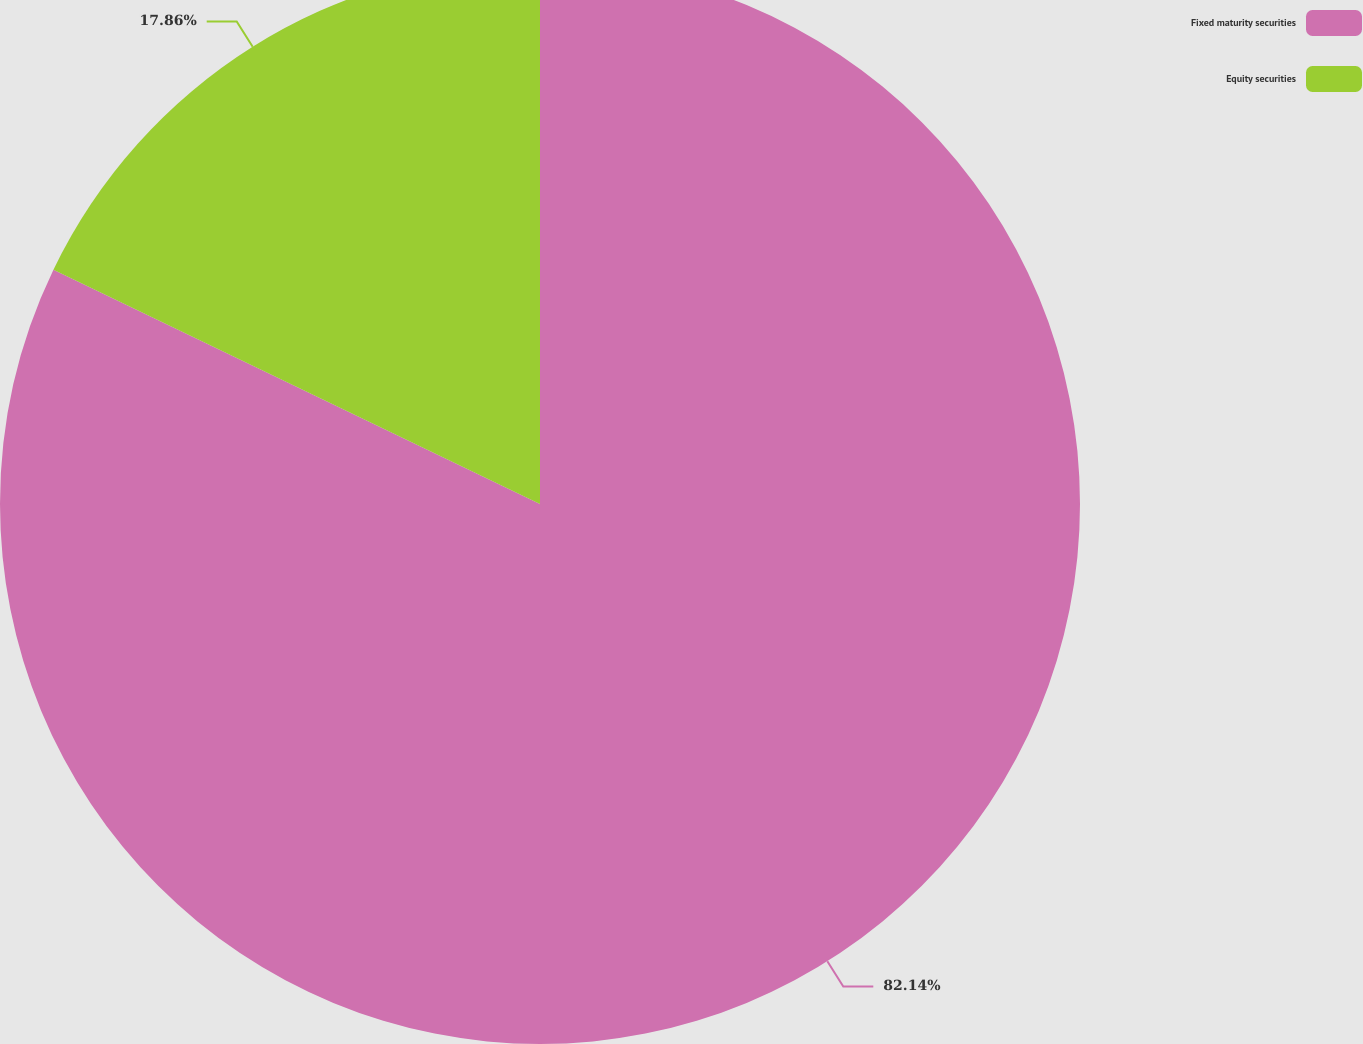Convert chart to OTSL. <chart><loc_0><loc_0><loc_500><loc_500><pie_chart><fcel>Fixed maturity securities<fcel>Equity securities<nl><fcel>82.14%<fcel>17.86%<nl></chart> 